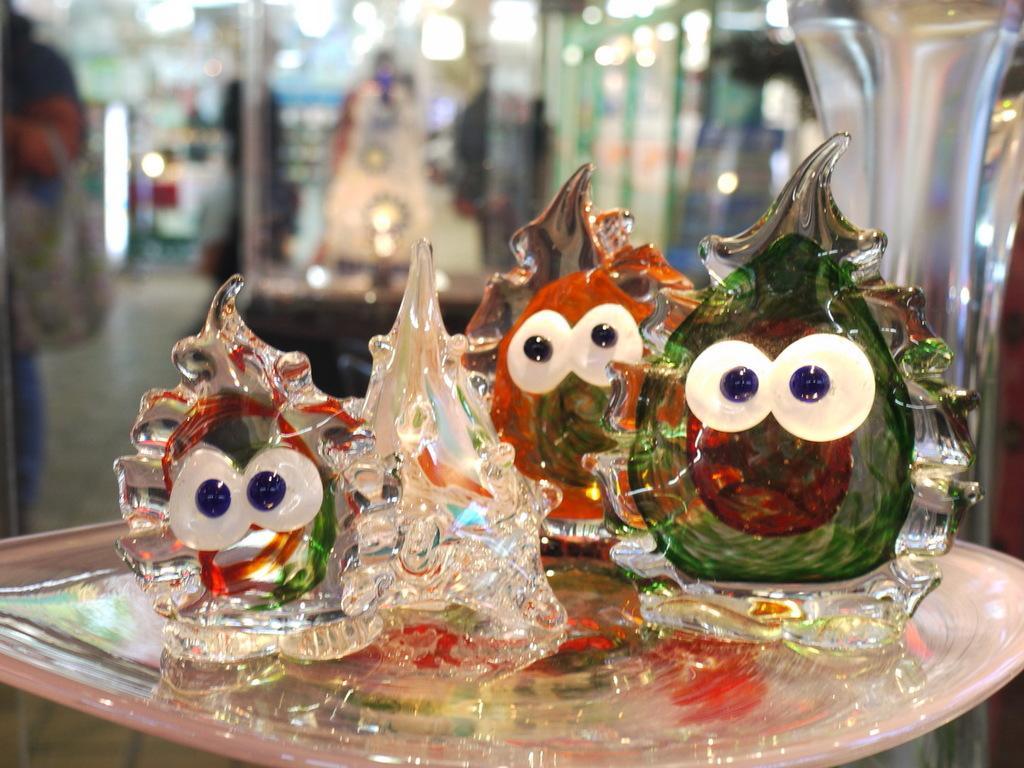Could you give a brief overview of what you see in this image? In this image I can see few glass toys in the plate and the plate is in white color and I can see blurred background. 